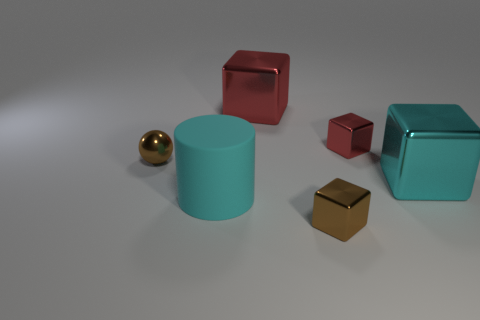Add 2 big red shiny blocks. How many objects exist? 8 Subtract all cylinders. How many objects are left? 5 Subtract 1 cubes. How many cubes are left? 3 Subtract all red blocks. Subtract all purple balls. How many blocks are left? 2 Subtract all gray balls. How many brown cubes are left? 1 Subtract all red shiny cubes. Subtract all cyan metal cubes. How many objects are left? 3 Add 6 tiny red things. How many tiny red things are left? 7 Add 5 tiny blue metal blocks. How many tiny blue metal blocks exist? 5 Subtract all brown cubes. How many cubes are left? 3 Subtract 0 yellow blocks. How many objects are left? 6 